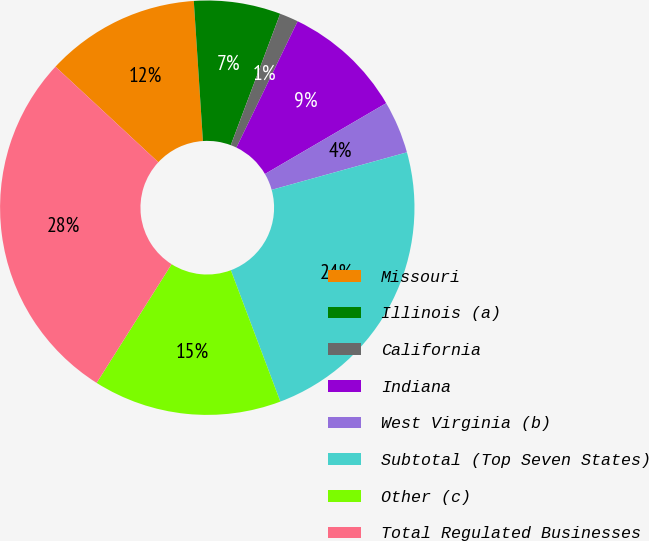<chart> <loc_0><loc_0><loc_500><loc_500><pie_chart><fcel>Missouri<fcel>Illinois (a)<fcel>California<fcel>Indiana<fcel>West Virginia (b)<fcel>Subtotal (Top Seven States)<fcel>Other (c)<fcel>Total Regulated Businesses<nl><fcel>12.05%<fcel>6.76%<fcel>1.46%<fcel>9.4%<fcel>4.11%<fcel>23.57%<fcel>14.7%<fcel>27.95%<nl></chart> 